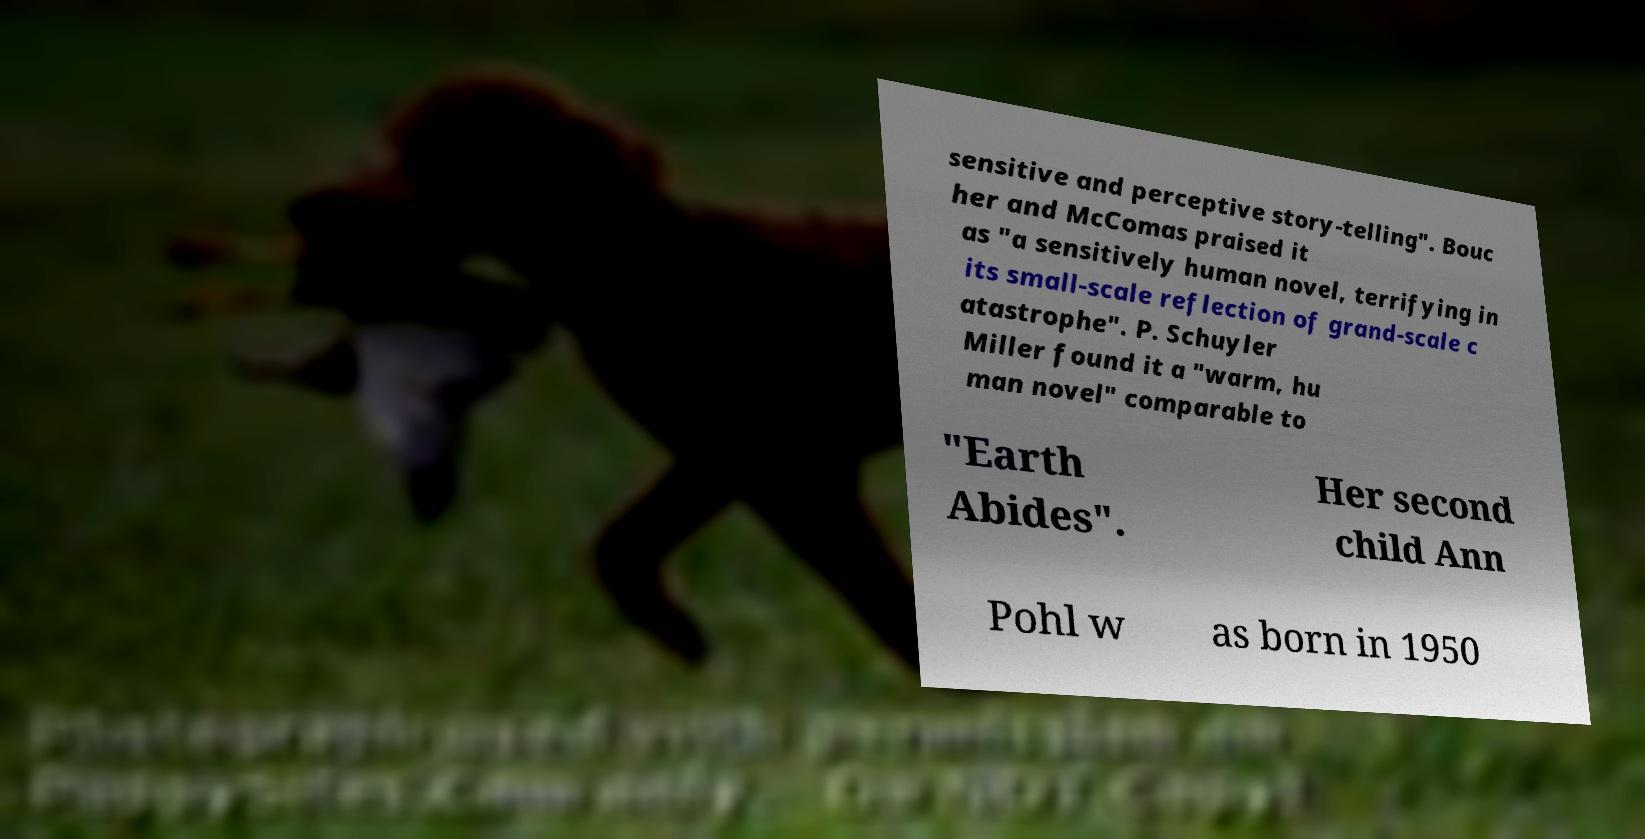Can you read and provide the text displayed in the image?This photo seems to have some interesting text. Can you extract and type it out for me? sensitive and perceptive story-telling". Bouc her and McComas praised it as "a sensitively human novel, terrifying in its small-scale reflection of grand-scale c atastrophe". P. Schuyler Miller found it a "warm, hu man novel" comparable to "Earth Abides". Her second child Ann Pohl w as born in 1950 